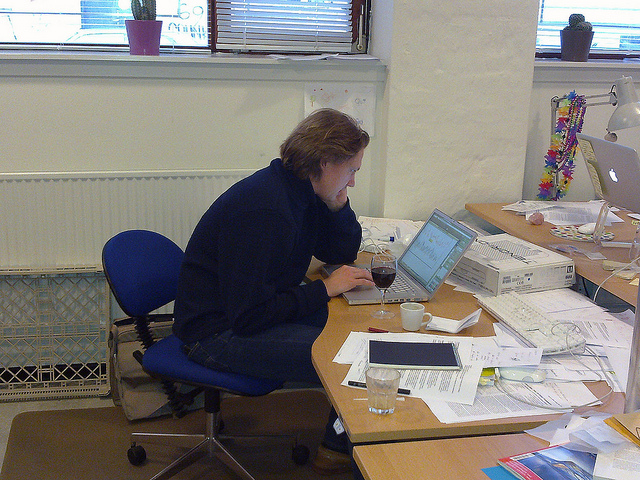What possible tasks might the person in the image be working on, based on the visible contents of their desk? Based on the items scattered on the desk, the person might be engaged in tasks that involve paperwork, such as administrative work, financial planning, or project management. The visible charts and graphs suggest data analysis or strategic planning activities. Additionally, the presence of a laptop indicates that they may also be performing digital tasks like writing reports, managing emails, or participating in virtual meetings. What does the presence of personal items, like the glass of wine, indicate about the person's work habits or environment? The presence of a glass of wine might suggest that the person is working late hours or trying to create a more relaxed atmosphere to cope with stress. It might also reflect a blend of personal and professional time, potentially indicating a work-from-home situation or a more casual office culture where such liberties are allowed. 